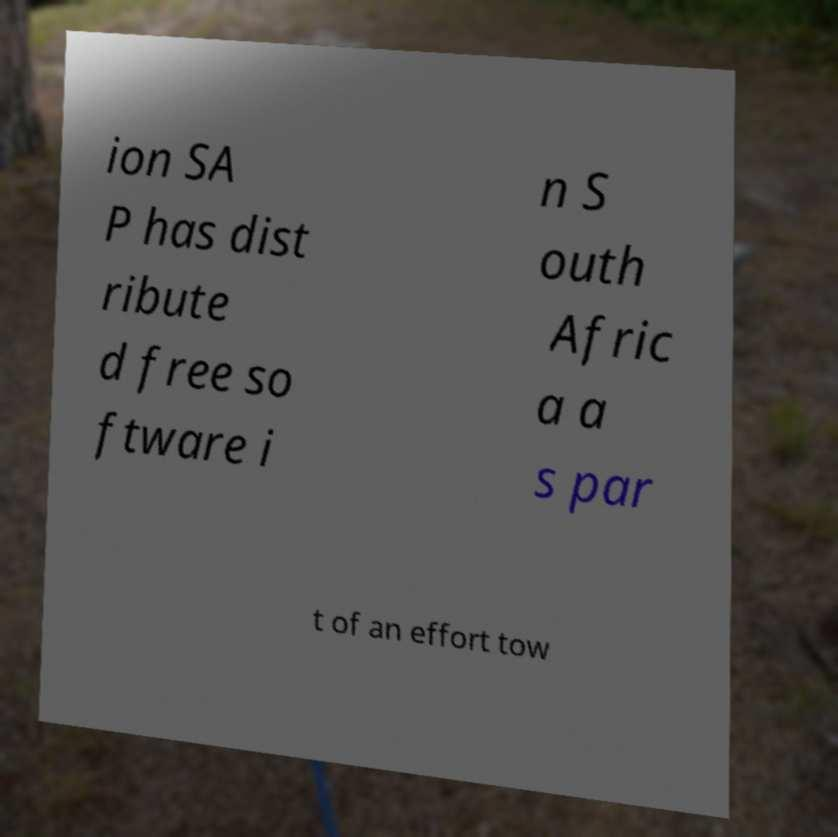Could you assist in decoding the text presented in this image and type it out clearly? ion SA P has dist ribute d free so ftware i n S outh Afric a a s par t of an effort tow 